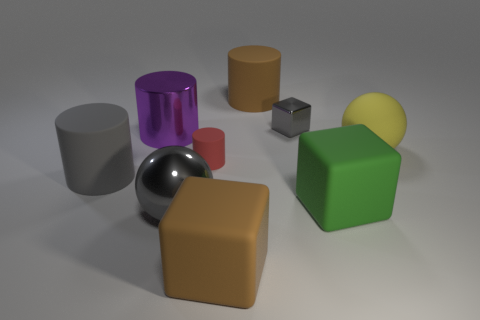What number of cubes are big green matte things or big rubber objects?
Give a very brief answer. 2. How many other objects are the same material as the brown cube?
Provide a short and direct response. 5. What is the shape of the large rubber thing that is left of the large metal cylinder?
Offer a very short reply. Cylinder. The big ball that is to the right of the brown rubber object that is in front of the big yellow rubber object is made of what material?
Provide a short and direct response. Rubber. Are there more big brown matte things in front of the purple object than brown rubber balls?
Provide a short and direct response. Yes. What number of other objects are the same color as the tiny rubber object?
Make the answer very short. 0. What shape is the green thing that is the same size as the yellow matte sphere?
Ensure brevity in your answer.  Cube. What number of big rubber cylinders are left of the large matte cylinder that is to the left of the brown thing that is in front of the purple thing?
Ensure brevity in your answer.  0. How many matte objects are either gray balls or big gray objects?
Ensure brevity in your answer.  1. The cylinder that is both on the right side of the big gray cylinder and in front of the yellow object is what color?
Offer a very short reply. Red. 